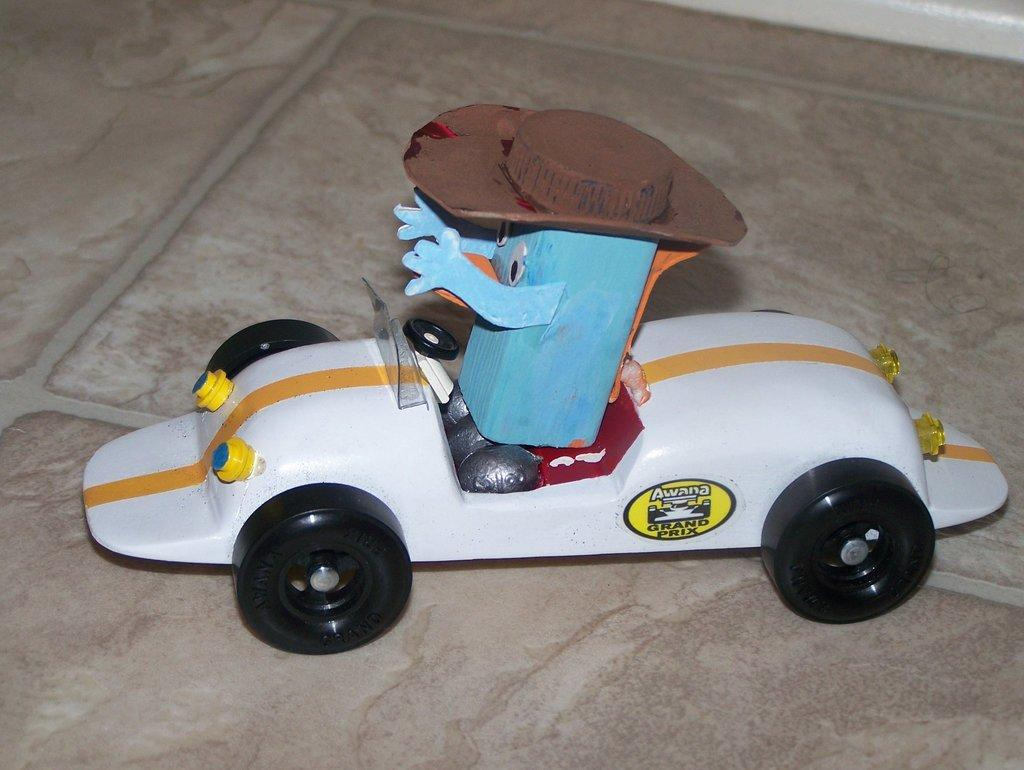What is the main object in the foreground of the image? There is a cardboard toy in the foreground of the image. What is the toy placed on? The toy is on a white car. Can you describe the surface the car is on? The car is on a surface, but the specific type of surface is not mentioned in the facts. What type of calculator is visible on the toy's chin in the image? There is no calculator or chin present on the toy in the image. 